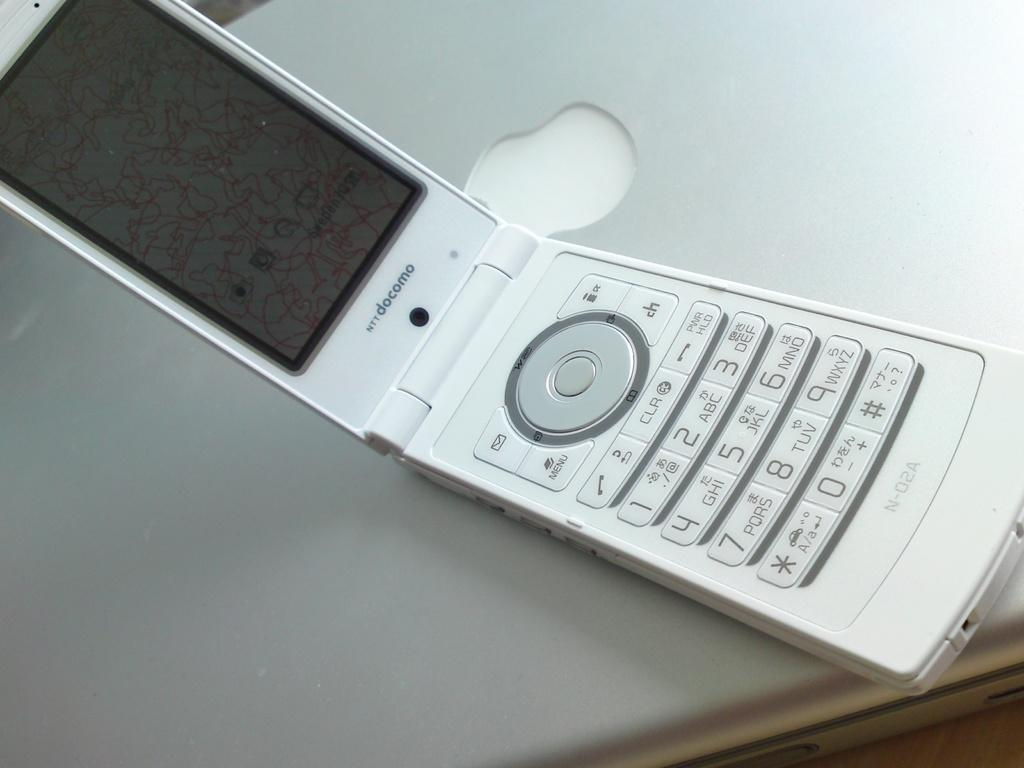<image>
Share a concise interpretation of the image provided. An open flip phone with the serial number N-02A printed on the bottom 